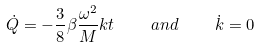Convert formula to latex. <formula><loc_0><loc_0><loc_500><loc_500>\dot { Q } = - \frac { 3 } { 8 } \beta \frac { \omega ^ { 2 } } { M } k t \quad a n d \quad \dot { k } = 0</formula> 